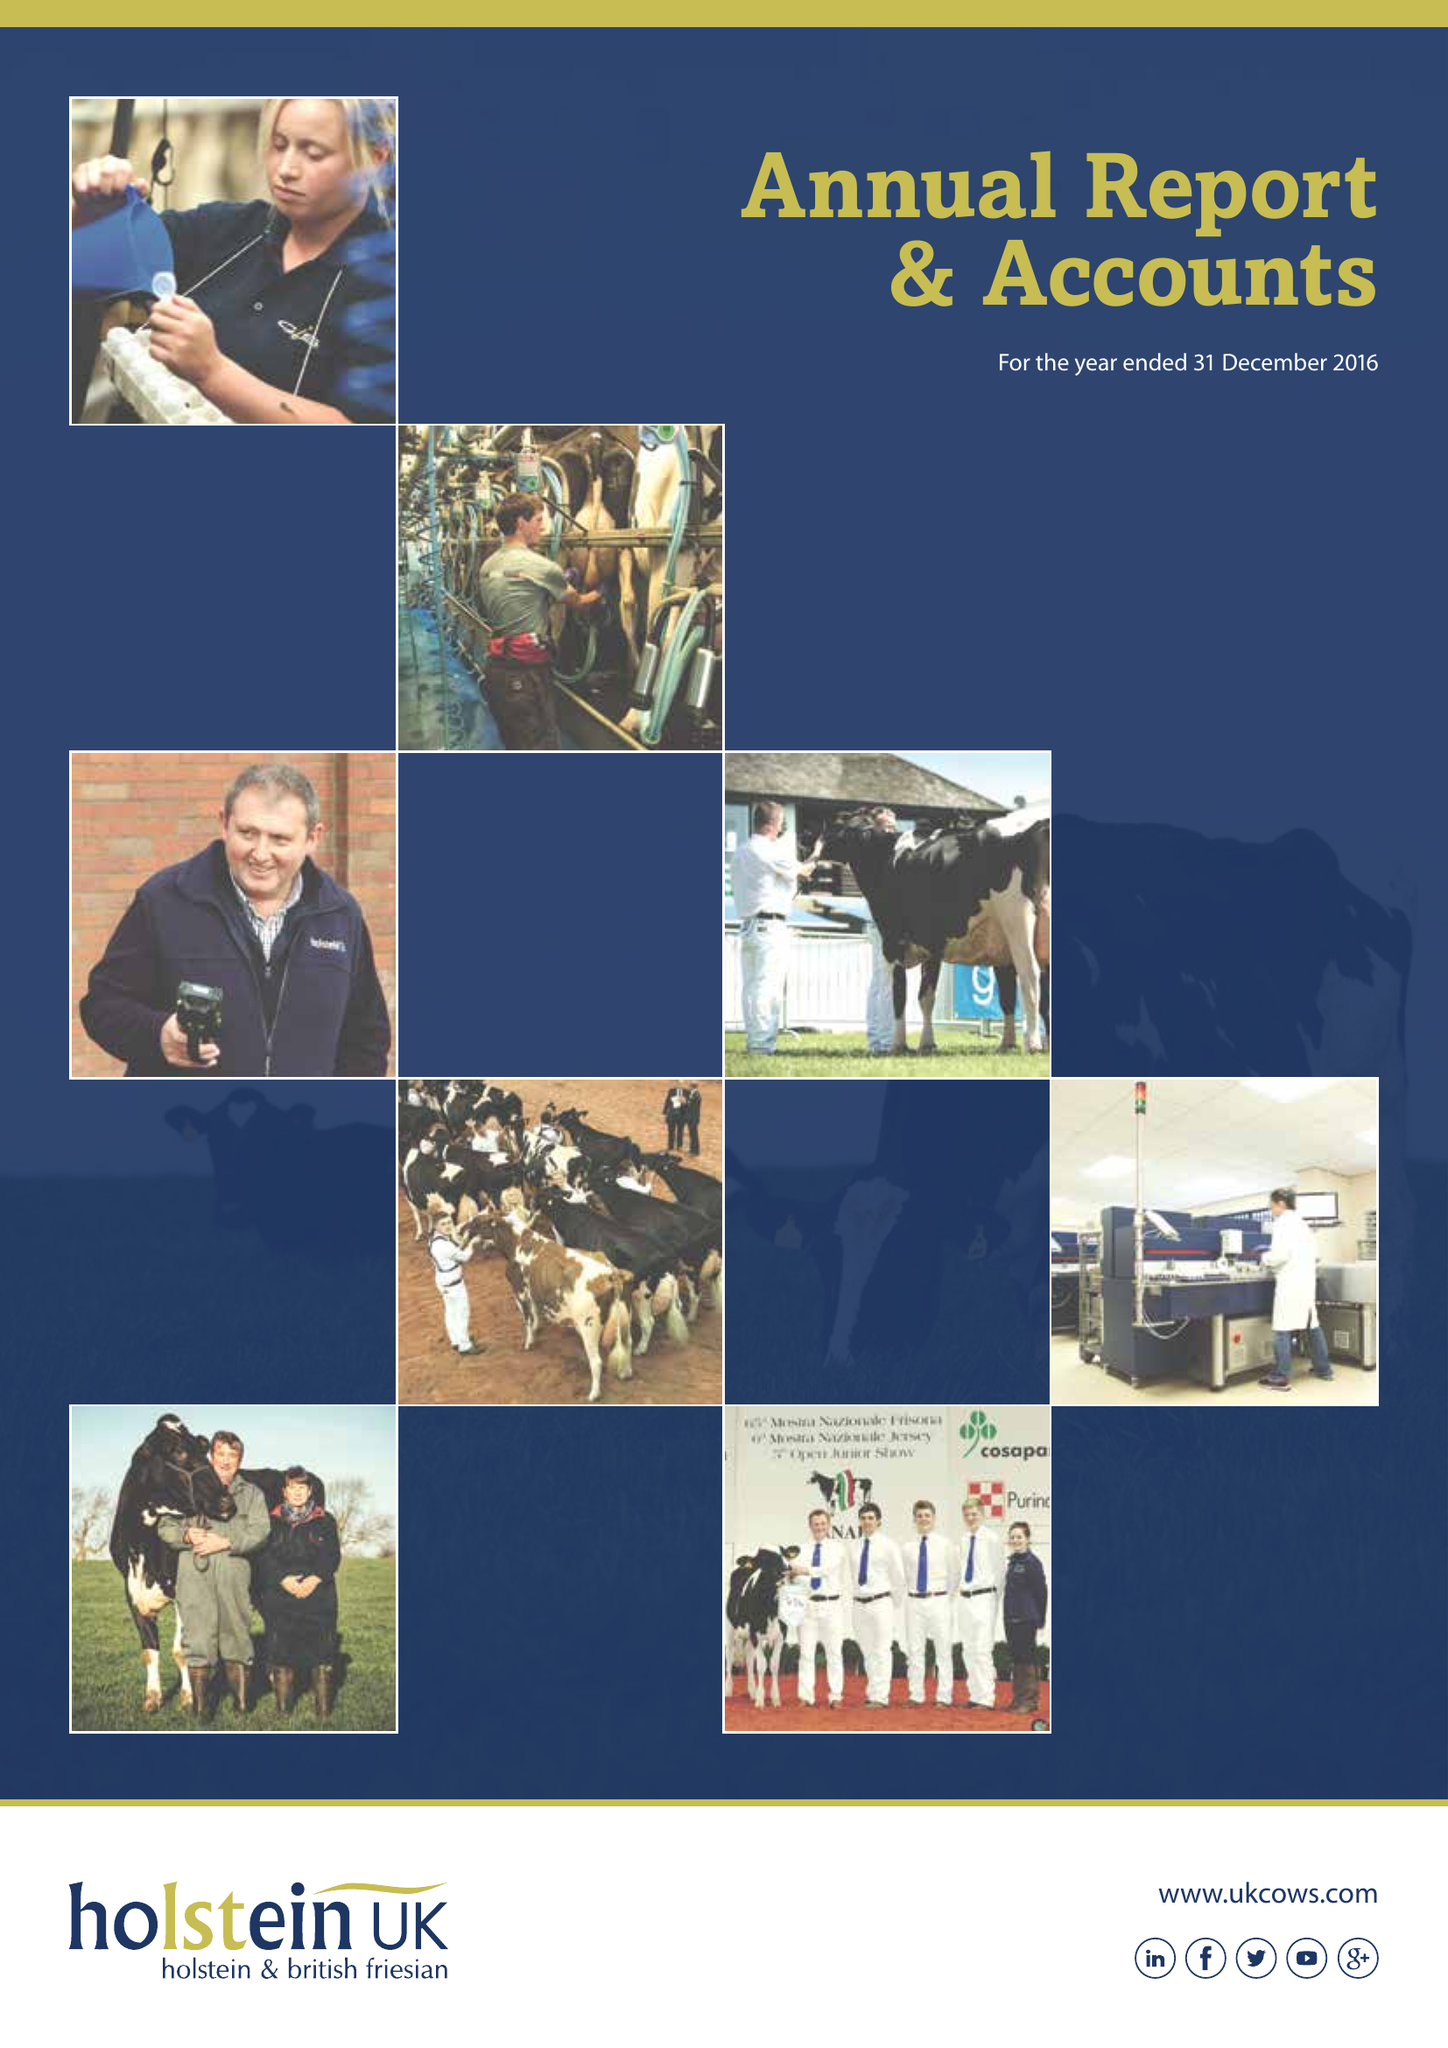What is the value for the address__postcode?
Answer the question using a single word or phrase. TF3 3BD 